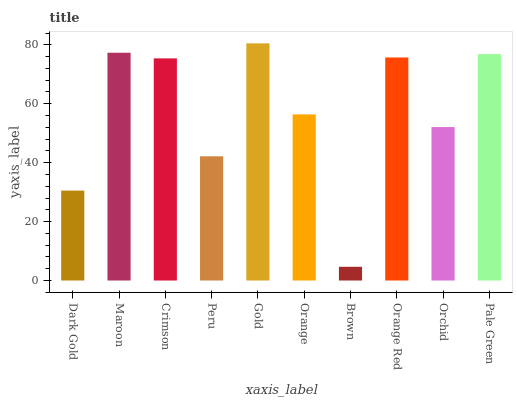Is Brown the minimum?
Answer yes or no. Yes. Is Gold the maximum?
Answer yes or no. Yes. Is Maroon the minimum?
Answer yes or no. No. Is Maroon the maximum?
Answer yes or no. No. Is Maroon greater than Dark Gold?
Answer yes or no. Yes. Is Dark Gold less than Maroon?
Answer yes or no. Yes. Is Dark Gold greater than Maroon?
Answer yes or no. No. Is Maroon less than Dark Gold?
Answer yes or no. No. Is Crimson the high median?
Answer yes or no. Yes. Is Orange the low median?
Answer yes or no. Yes. Is Orchid the high median?
Answer yes or no. No. Is Maroon the low median?
Answer yes or no. No. 